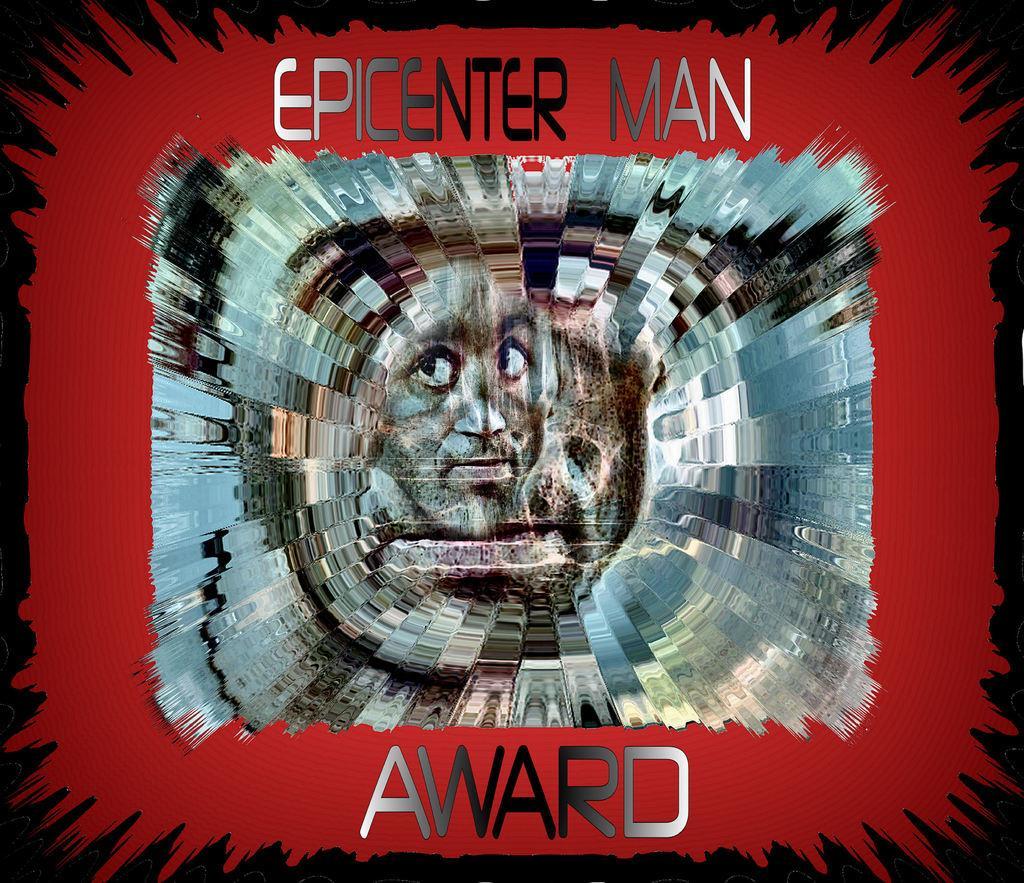How would you summarize this image in a sentence or two? This is an edited image, in this picture we can see a person face and text. In the background of the image it is dark. 